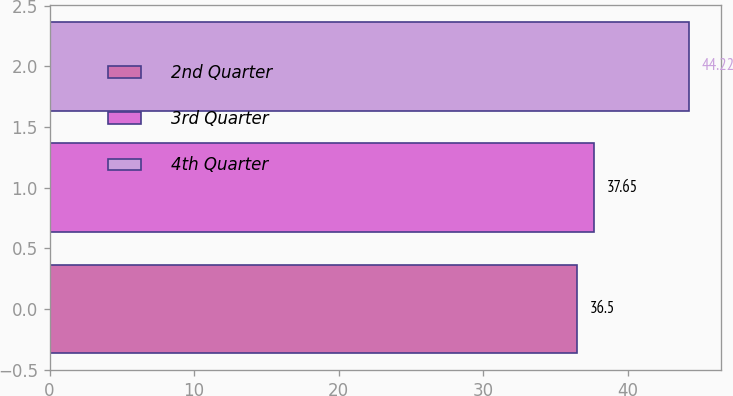Convert chart. <chart><loc_0><loc_0><loc_500><loc_500><bar_chart><fcel>2nd Quarter<fcel>3rd Quarter<fcel>4th Quarter<nl><fcel>36.5<fcel>37.65<fcel>44.22<nl></chart> 